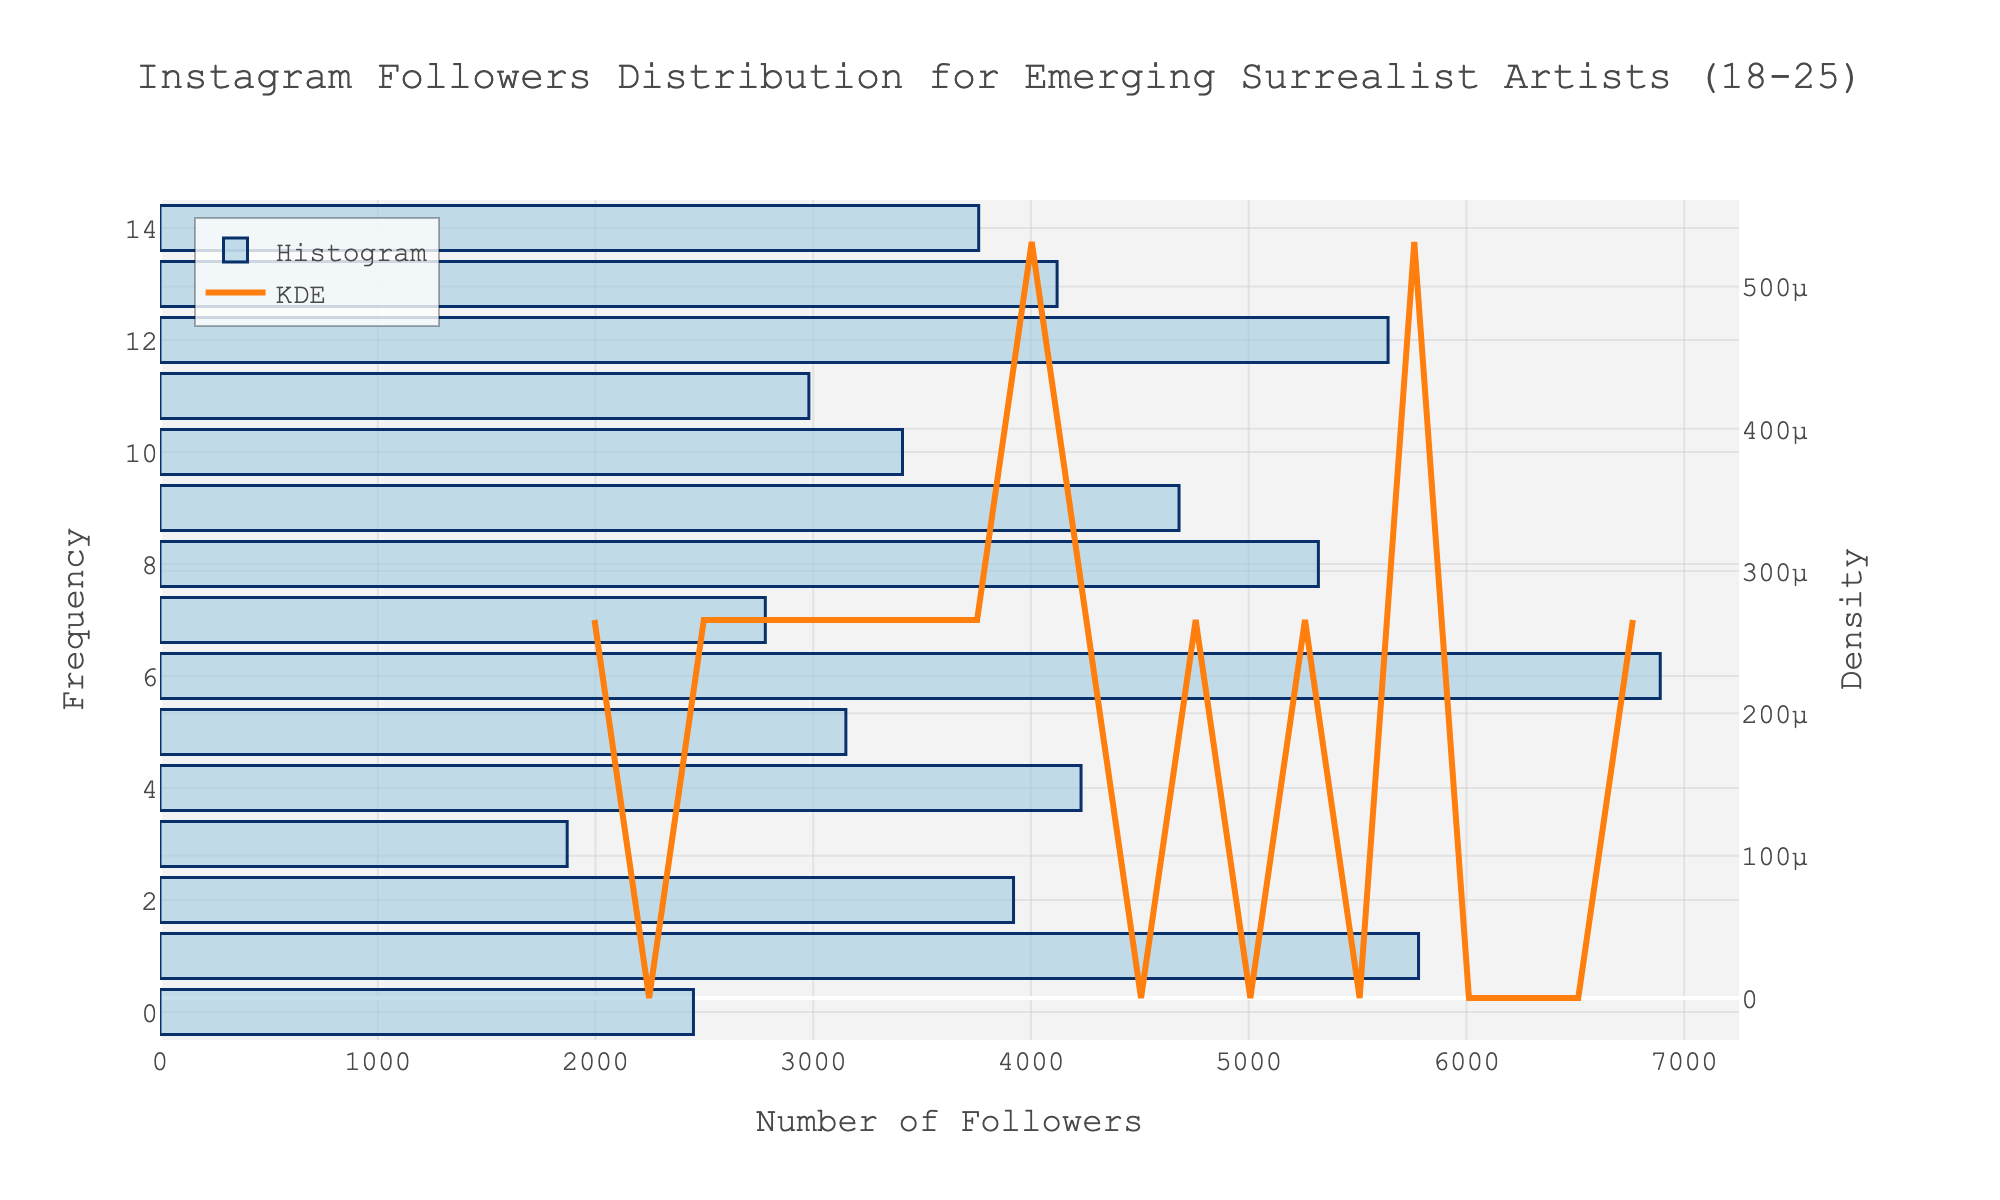What's the title of the figure? The title is written at the top of the figure, centered and in a larger font size. It explains what the histogram and KDE represent.
Answer: Instagram Followers Distribution for Emerging Surrealist Artists (18-25) What's the x-axis label? The label for the x-axis is directly under the horizontal line of the plot. It provides context regarding what the numeric values on the axis represent.
Answer: Number of Followers How many artists have between 3000 and 4000 followers? To answer this, look at the height of the histogram bars corresponding to the x-axis range of 3000 to 4000.
Answer: 5 Which artist has the highest number of followers? By examining the histogram and matching the highest bar to the data, we find the artist with the most followers.
Answer: Mia Rodriguez What is the density peak in the KDE curve? The highest point of the KDE curve indicates the peak density of the distribution of followers.
Answer: Around 4000 followers Which artist has the number of followers closest to the KDE peak? By comparing the KDE peak value to individual data points in the histogram, identify the closest match.
Answer: Zoe Patel How does the number of followers of Sarah Thompson compare with those of Oscar Svensson? Look at the positions of the bars corresponding to Sarah Thompson and Oscar Svensson and compare their heights.
Answer: Sarah Thompson has fewer followers than Oscar Svensson Why might the histogram and KDE curve be useful together? The histogram provides the frequency of data, while the KDE curve smooths out the distribution to show the probability density. Together, they offer a detailed view of the data distribution.
Answer: Complementary insights on data distribution What general pattern can be observed about the number of Instagram followers for these emerging surrealist artists? Analyze the overall shape and spread of the histogram and KDE curve to identify any general trends or patterns.
Answer: Most artists have between 2500 and 6000 followers Which artists could be considered outliers based on the histogram? Outliers would be significantly different from the majority of data points. Look for bars farthest from the main groupings.
Answer: Mia Rodriguez (6890 followers), Alex Kovacs (1870 followers) 